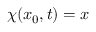<formula> <loc_0><loc_0><loc_500><loc_500>\chi ( x _ { 0 } , t ) = x</formula> 